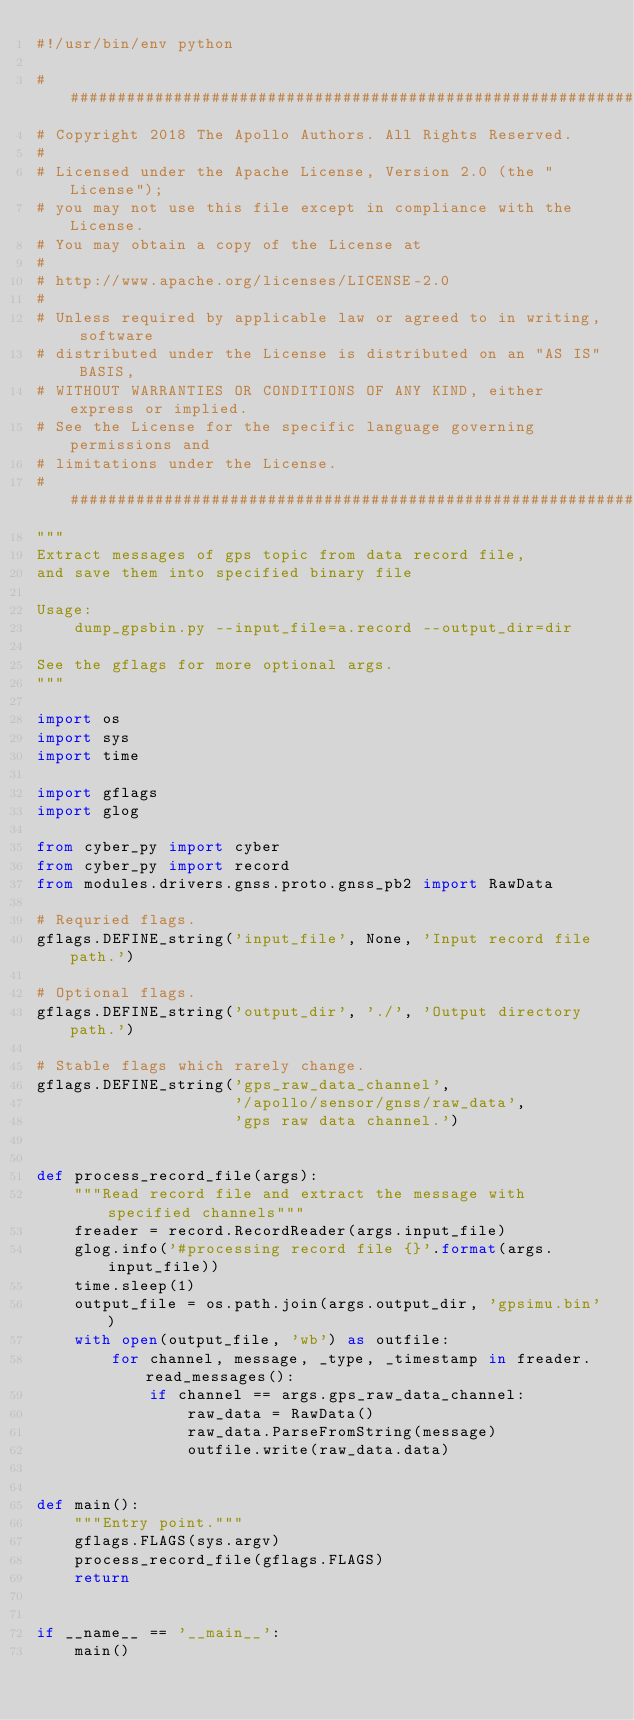<code> <loc_0><loc_0><loc_500><loc_500><_Python_>#!/usr/bin/env python

###############################################################################
# Copyright 2018 The Apollo Authors. All Rights Reserved.
#
# Licensed under the Apache License, Version 2.0 (the "License");
# you may not use this file except in compliance with the License.
# You may obtain a copy of the License at
#
# http://www.apache.org/licenses/LICENSE-2.0
#
# Unless required by applicable law or agreed to in writing, software
# distributed under the License is distributed on an "AS IS" BASIS,
# WITHOUT WARRANTIES OR CONDITIONS OF ANY KIND, either express or implied.
# See the License for the specific language governing permissions and
# limitations under the License.
###############################################################################
"""
Extract messages of gps topic from data record file,
and save them into specified binary file

Usage:
    dump_gpsbin.py --input_file=a.record --output_dir=dir

See the gflags for more optional args.
"""

import os
import sys
import time

import gflags
import glog

from cyber_py import cyber
from cyber_py import record
from modules.drivers.gnss.proto.gnss_pb2 import RawData

# Requried flags.
gflags.DEFINE_string('input_file', None, 'Input record file path.')

# Optional flags.
gflags.DEFINE_string('output_dir', './', 'Output directory path.')

# Stable flags which rarely change.
gflags.DEFINE_string('gps_raw_data_channel',
                     '/apollo/sensor/gnss/raw_data',
                     'gps raw data channel.')


def process_record_file(args):
    """Read record file and extract the message with specified channels"""
    freader = record.RecordReader(args.input_file)
    glog.info('#processing record file {}'.format(args.input_file))
    time.sleep(1)
    output_file = os.path.join(args.output_dir, 'gpsimu.bin')
    with open(output_file, 'wb') as outfile:
        for channel, message, _type, _timestamp in freader.read_messages():
            if channel == args.gps_raw_data_channel:
                raw_data = RawData()
                raw_data.ParseFromString(message)
                outfile.write(raw_data.data)


def main():
    """Entry point."""
    gflags.FLAGS(sys.argv)
    process_record_file(gflags.FLAGS)
    return


if __name__ == '__main__':
    main()
</code> 